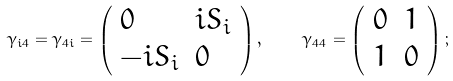<formula> <loc_0><loc_0><loc_500><loc_500>\gamma _ { i 4 } = \gamma _ { 4 i } = \left ( \begin{array} { l l } { 0 } & { { i S _ { i } } } \\ { { - i S _ { i } } } & { 0 } \end{array} \right ) , \quad \ \gamma _ { 4 4 } = \left ( \begin{array} { l l } { 0 } & { 1 } \\ { 1 } & { 0 } \end{array} \right ) ;</formula> 